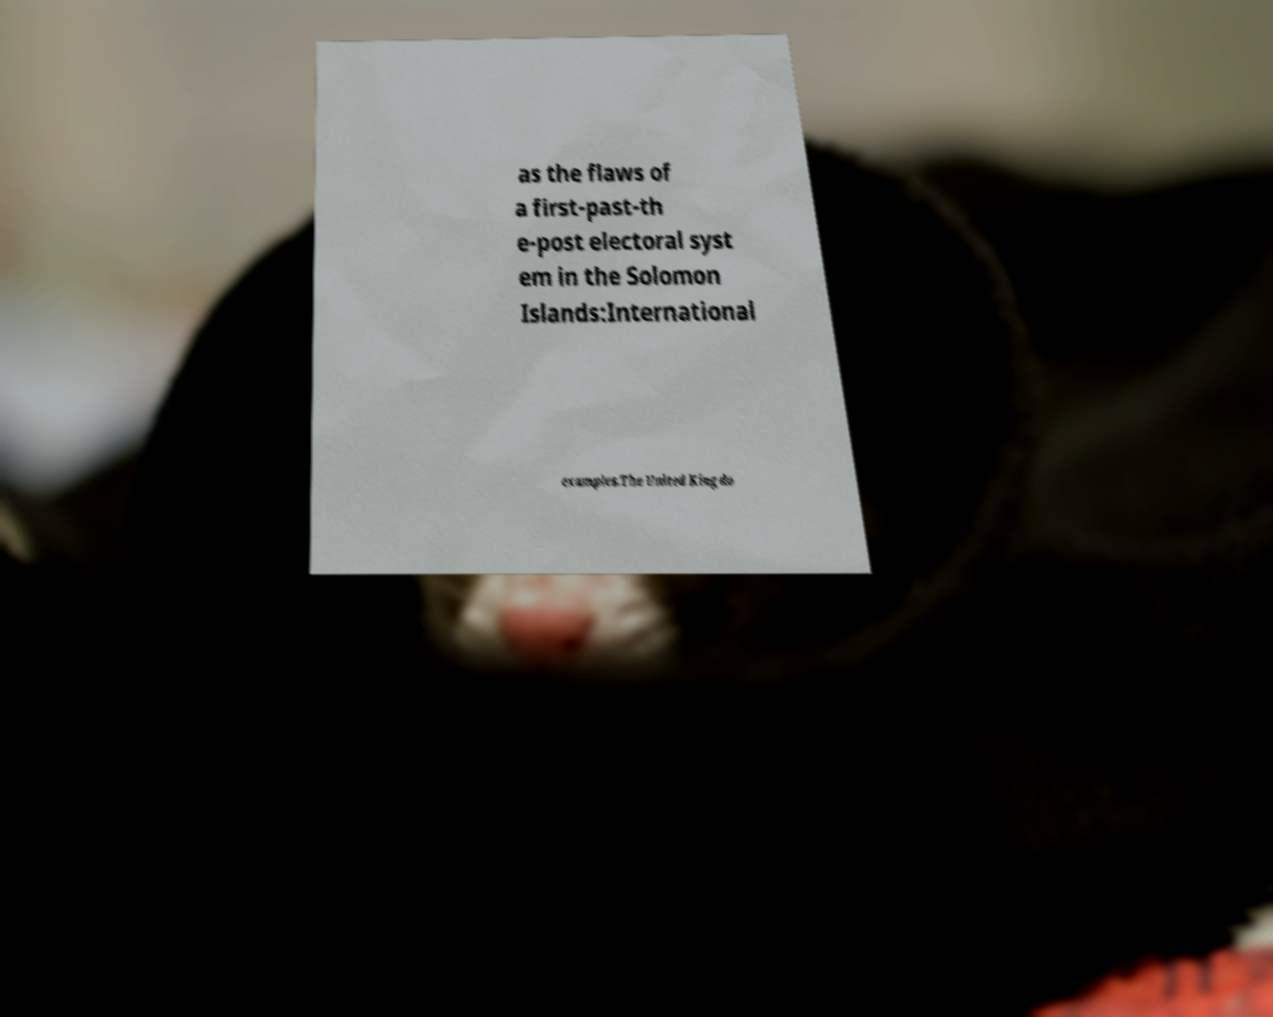There's text embedded in this image that I need extracted. Can you transcribe it verbatim? as the flaws of a first-past-th e-post electoral syst em in the Solomon Islands:International examples.The United Kingdo 